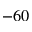<formula> <loc_0><loc_0><loc_500><loc_500>- 6 0</formula> 